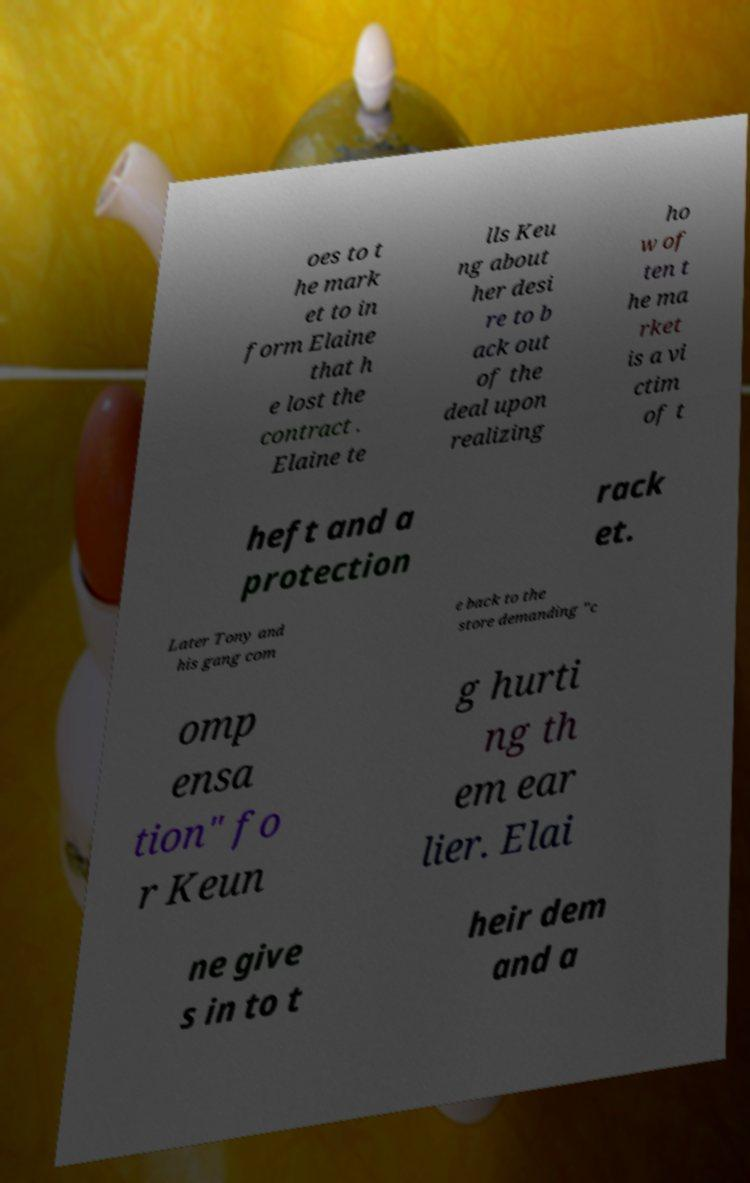There's text embedded in this image that I need extracted. Can you transcribe it verbatim? oes to t he mark et to in form Elaine that h e lost the contract . Elaine te lls Keu ng about her desi re to b ack out of the deal upon realizing ho w of ten t he ma rket is a vi ctim of t heft and a protection rack et. Later Tony and his gang com e back to the store demanding "c omp ensa tion" fo r Keun g hurti ng th em ear lier. Elai ne give s in to t heir dem and a 